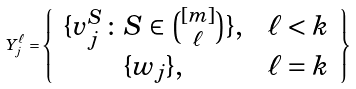Convert formula to latex. <formula><loc_0><loc_0><loc_500><loc_500>Y _ { j } ^ { \ell } = \left \{ \begin{array} { c c } \{ v _ { j } ^ { S } \colon S \in { [ m ] \choose \ell } \} , & \ \ell < k \\ \{ w _ { j } \} , & \ \ell = k \end{array} \right \}</formula> 